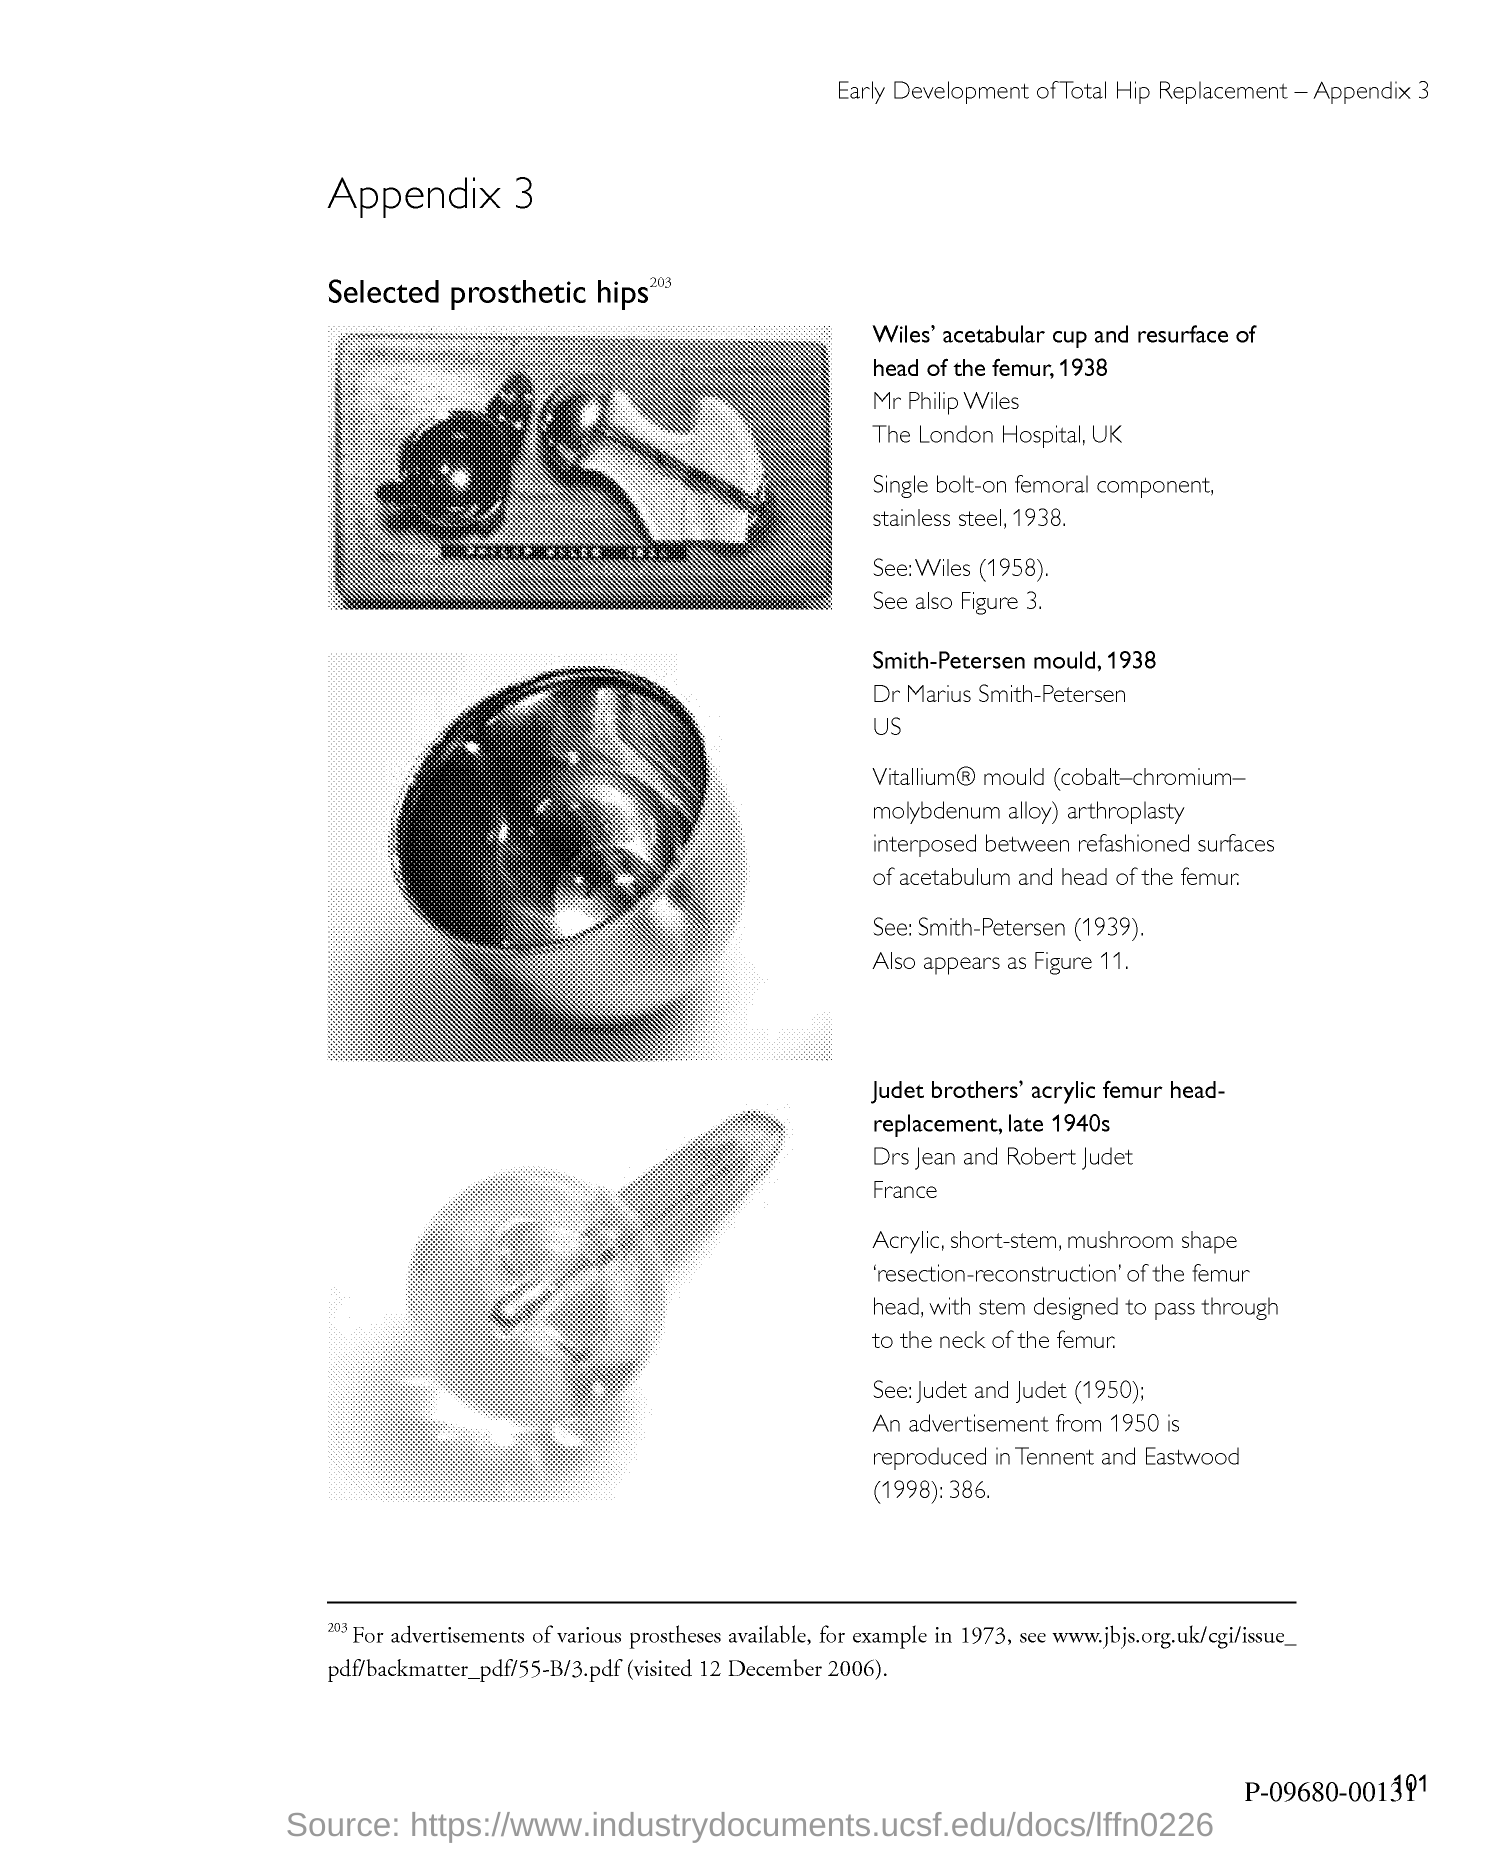List a handful of essential elements in this visual. The page number is 101. The title of the document is Appendix 3. 